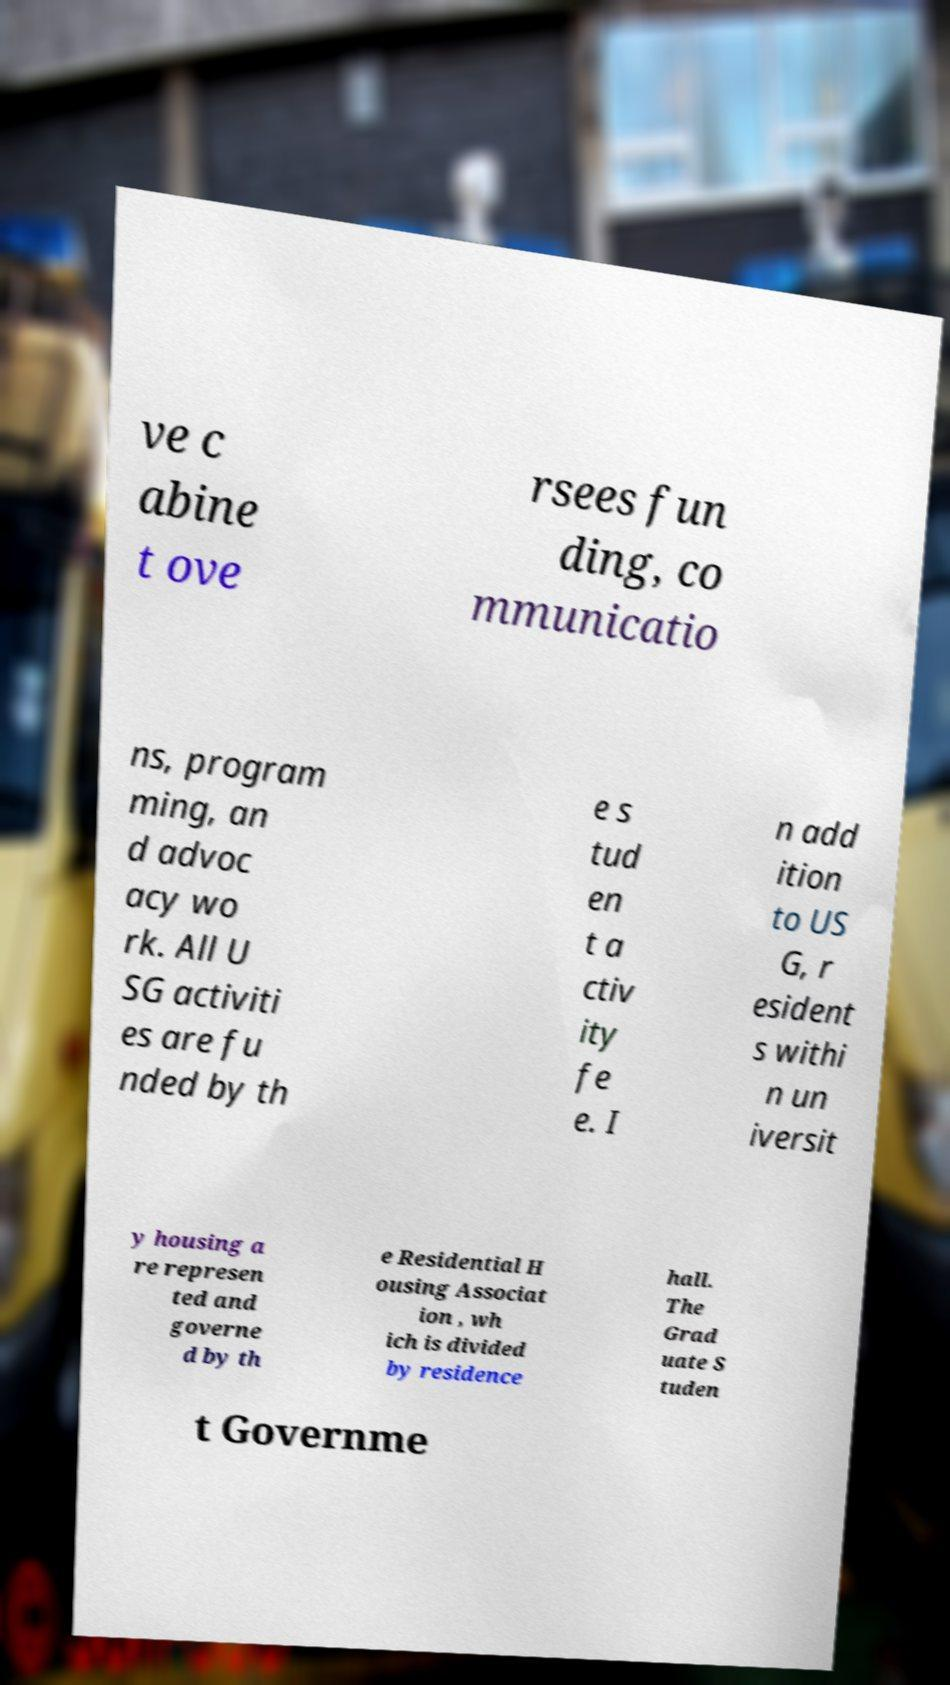For documentation purposes, I need the text within this image transcribed. Could you provide that? ve c abine t ove rsees fun ding, co mmunicatio ns, program ming, an d advoc acy wo rk. All U SG activiti es are fu nded by th e s tud en t a ctiv ity fe e. I n add ition to US G, r esident s withi n un iversit y housing a re represen ted and governe d by th e Residential H ousing Associat ion , wh ich is divided by residence hall. The Grad uate S tuden t Governme 